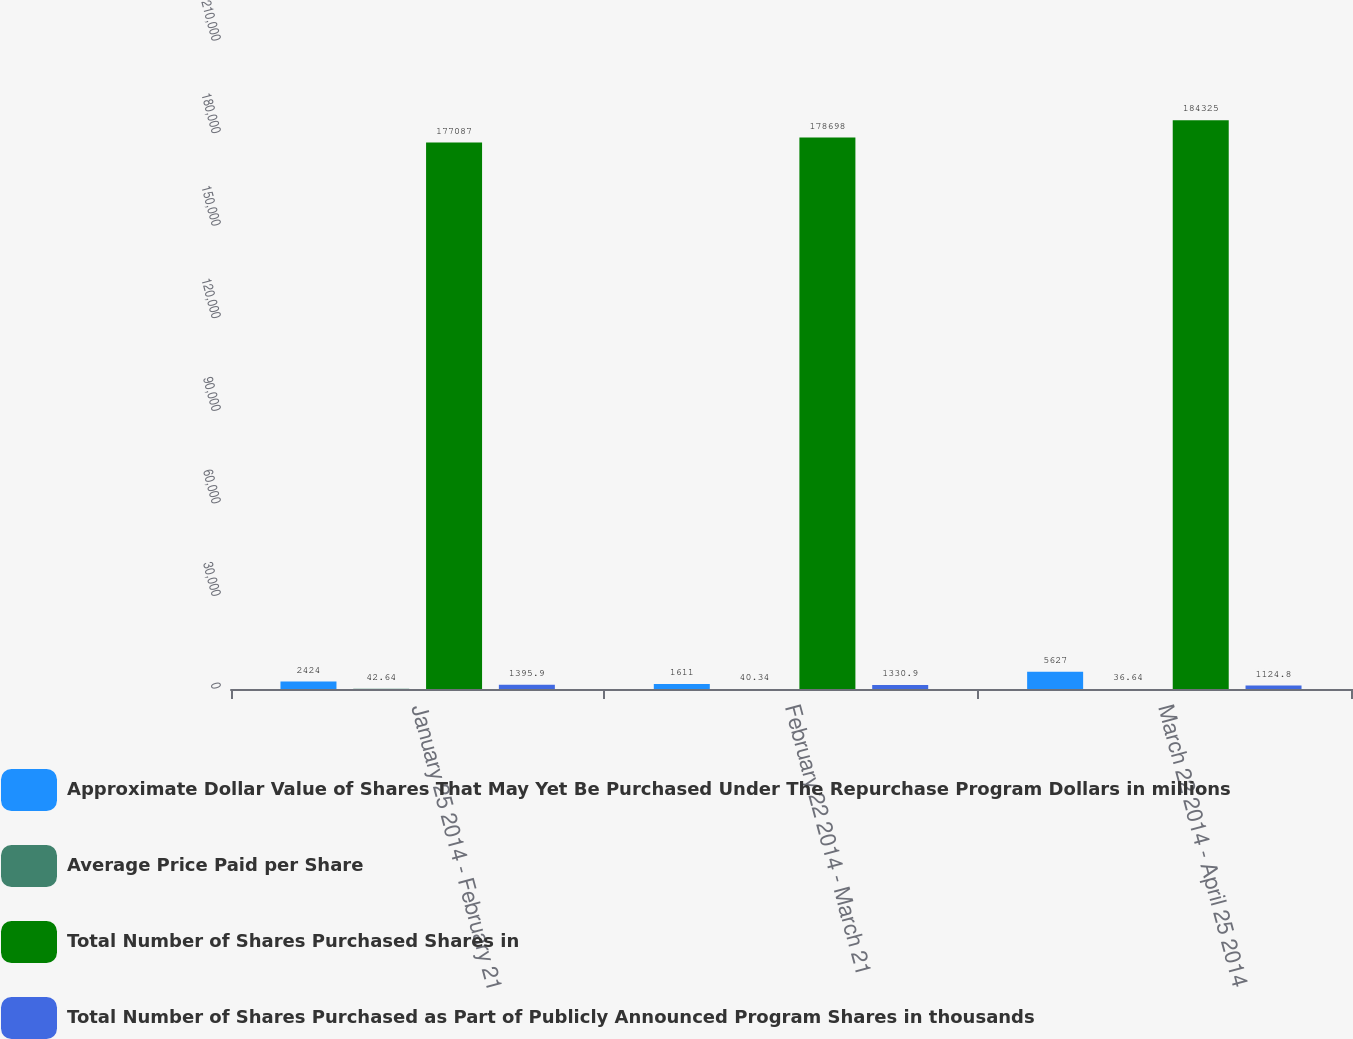Convert chart. <chart><loc_0><loc_0><loc_500><loc_500><stacked_bar_chart><ecel><fcel>January 25 2014 - February 21<fcel>February 22 2014 - March 21<fcel>March 22 2014 - April 25 2014<nl><fcel>Approximate Dollar Value of Shares That May Yet Be Purchased Under The Repurchase Program Dollars in millions<fcel>2424<fcel>1611<fcel>5627<nl><fcel>Average Price Paid per Share<fcel>42.64<fcel>40.34<fcel>36.64<nl><fcel>Total Number of Shares Purchased Shares in<fcel>177087<fcel>178698<fcel>184325<nl><fcel>Total Number of Shares Purchased as Part of Publicly Announced Program Shares in thousands<fcel>1395.9<fcel>1330.9<fcel>1124.8<nl></chart> 